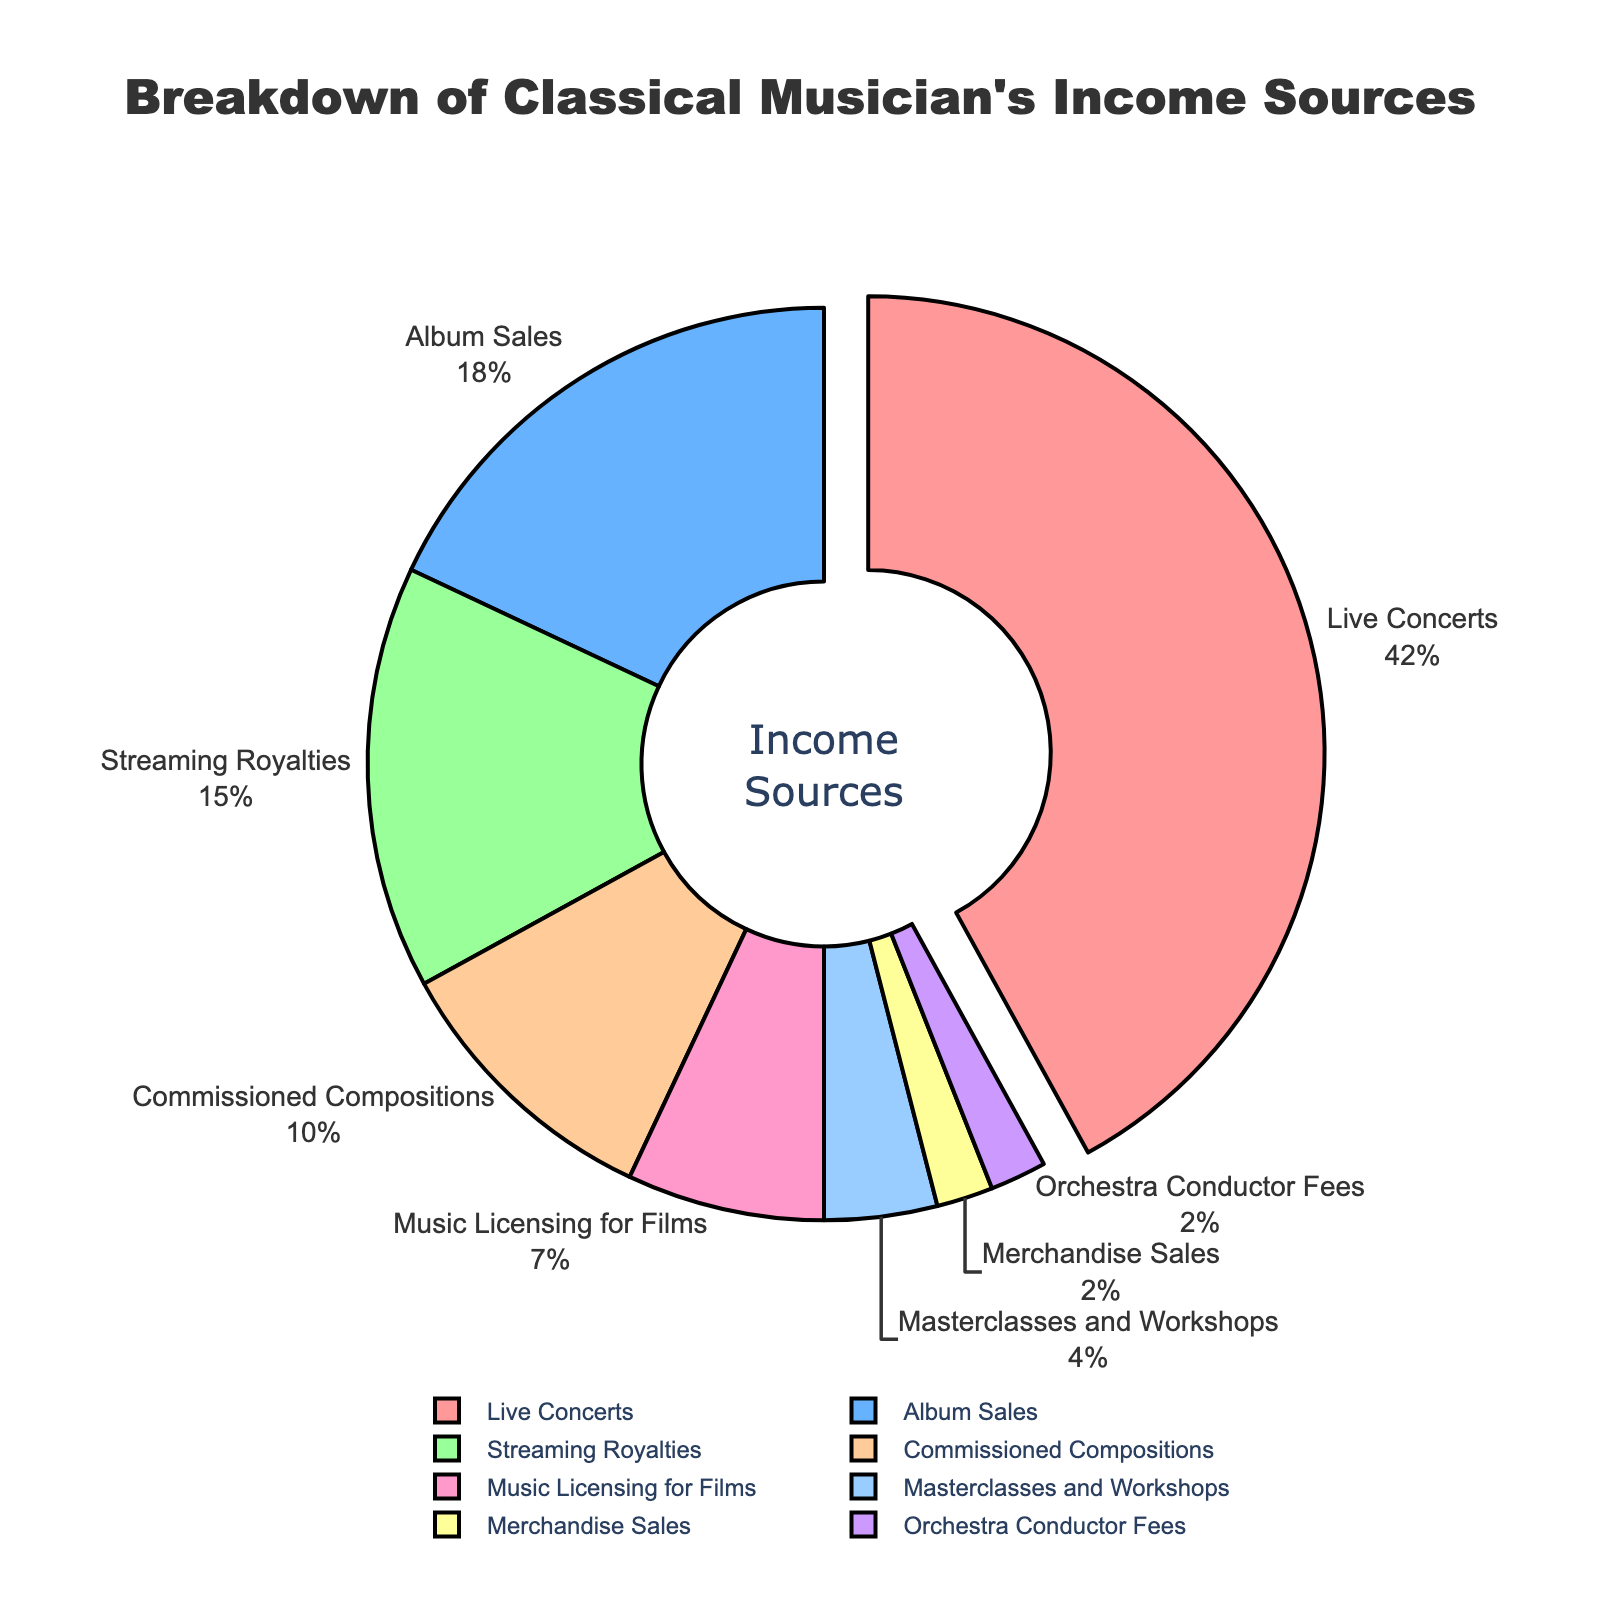What is the largest source of income for the musician? The largest source is indicated by the segment that is slightly pulled out from the rest, representing the highest percentage. According to the provided data, this is the Live Concerts segment with 42%.
Answer: Live Concerts What percentage of the musician's income comes from Album Sales and Streaming Royalties combined? To find the combined percentage, add the values for Album Sales (18%) and Streaming Royalties (15%). So, 18% + 15% equals 33%.
Answer: 33% Which income source contributes less to the musician's earnings, Merchandise Sales or Orchestra Conductor Fees? According to the provided data, both Merchandise Sales and Orchestra Conductor Fees each contribute 2%. Hence, they are equal.
Answer: They are equal How does the income from Music Licensing for Films compare to Commissioned Compositions? Music Licensing for Films contributes 7%, while Commissioned Compositions contribute 10%. Therefore, Commissioned Compositions have a higher contribution.
Answer: Commissioned Compositions What is the difference in percentage points between the highest and lowest income sources? The highest income source is Live Concerts with 42%, and the lowest sources are Merchandise Sales and Orchestra Conductor Fees, each with 2%. The difference is 42% - 2% = 40%.
Answer: 40% Which income source is represented by the green color in the pie chart? In the chart, the green color represents Streaming Royalties.
Answer: Streaming Royalties How do Masterclasses and Workshops compare to Music Licensing for Films in terms of income contribution? Masterclasses and Workshops contribute 4%, while Music Licensing for Films contribute 7%. Music Licensing for Films, therefore, contributes more.
Answer: Music Licensing for Films What proportion of the musician's income is derived from live performances, which include Live Concerts and Orchestra Conductor Fees? Live Concerts contribute 42% and Orchestra Conductor Fees contribute 2%. Combined, they contribute 42% + 2% = 44%.
Answer: 44% What percentage of the musician's income does not come from Live Concerts? The total percentage for all income sources is 100%. Subtracting the percentage for Live Concerts (42%) gives 100% - 42% = 58%.
Answer: 58% Which two income sources each constitute exactly 2% of the total income? According to the provided data, Merchandise Sales and Orchestra Conductor Fees each constitute 2%.
Answer: Merchandise Sales and Orchestra Conductor Fees 